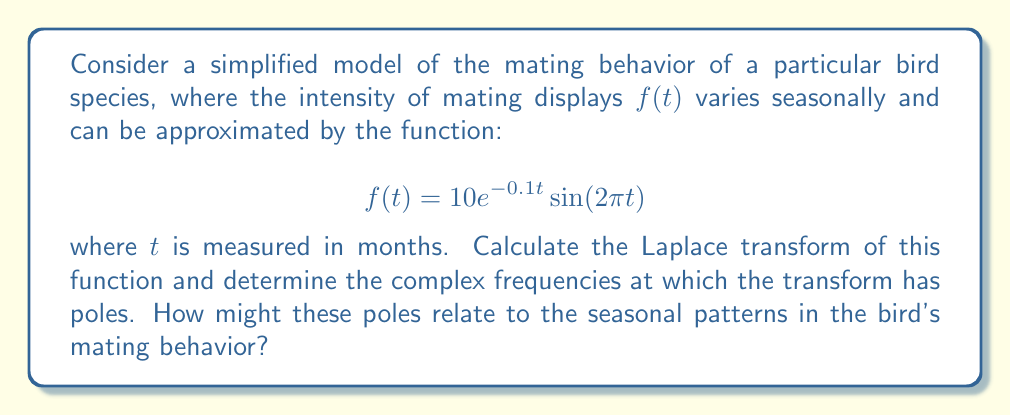Solve this math problem. Let's approach this step-by-step:

1) The Laplace transform of $f(t)$ is defined as:

   $$F(s) = \int_0^\infty f(t)e^{-st}dt$$

2) Substituting our function:

   $$F(s) = \int_0^\infty 10e^{-0.1t}\sin(2\pi t)e^{-st}dt$$

3) This can be rewritten as:

   $$F(s) = 10\int_0^\infty e^{-(s+0.1)t}\sin(2\pi t)dt$$

4) The Laplace transform of $e^{at}\sin(bt)$ is given by:

   $$\mathcal{L}\{e^{at}\sin(bt)\} = \frac{b}{(s-a)^2 + b^2}$$

5) In our case, $a = -0.1$ and $b = 2\pi$. Substituting:

   $$F(s) = 10 \cdot \frac{2\pi}{(s+0.1)^2 + (2\pi)^2}$$

6) Simplifying:

   $$F(s) = \frac{20\pi}{(s+0.1)^2 + 4\pi^2}$$

7) The poles of this function occur when the denominator equals zero:

   $$(s+0.1)^2 + 4\pi^2 = 0$$

8) Solving this equation:

   $$s+0.1 = \pm 2\pi i$$
   $$s = -0.1 \pm 2\pi i$$

9) These poles occur at complex frequencies. The real part (-0.1) represents the decay rate of the mating behavior over time. The imaginary part (±2πi) corresponds to the annual cycle of the mating behavior, as 2π in the time domain represents one complete cycle per year.

This analysis reveals that the mating behavior has a slight decay over time (possibly due to aging or environmental factors) and a strong annual periodicity, which aligns with the seasonal nature of bird mating behaviors.
Answer: The Laplace transform of the mating behavior function is:

$$F(s) = \frac{20\pi}{(s+0.1)^2 + 4\pi^2}$$

The poles occur at $s = -0.1 \pm 2\pi i$. These poles indicate an annual periodicity in the mating behavior (represented by the imaginary part ±2πi) with a slight decay over time (represented by the real part -0.1). 